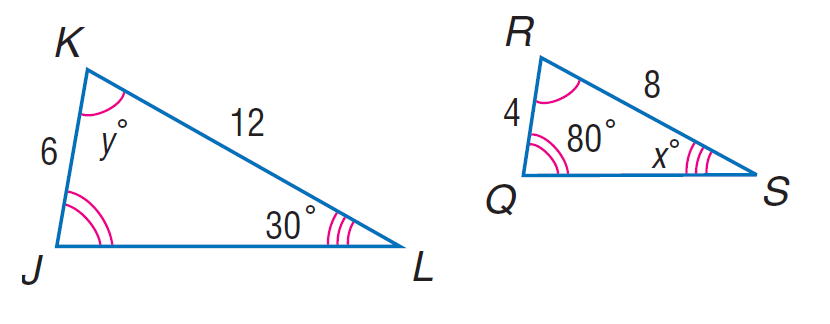Question: Each pair of polygons is similar. Find x.
Choices:
A. 30
B. 70
C. 80
D. 150
Answer with the letter. Answer: A Question: Each pair of polygons is similar. Find y.
Choices:
A. 70
B. 80
C. 100
D. 150
Answer with the letter. Answer: A 